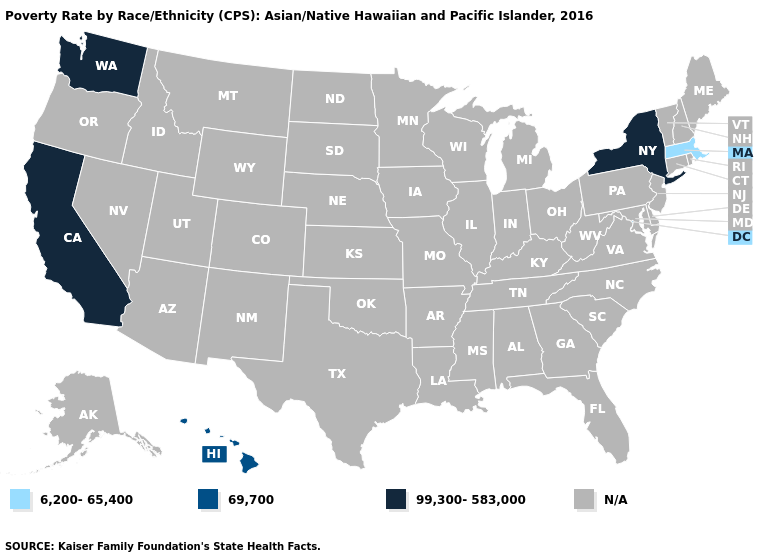What is the value of Arizona?
Give a very brief answer. N/A. Name the states that have a value in the range 99,300-583,000?
Be succinct. California, New York, Washington. Name the states that have a value in the range 6,200-65,400?
Quick response, please. Massachusetts. Does New York have the lowest value in the USA?
Concise answer only. No. Does New York have the highest value in the USA?
Be succinct. Yes. What is the value of Oregon?
Quick response, please. N/A. What is the value of Maryland?
Give a very brief answer. N/A. Name the states that have a value in the range 99,300-583,000?
Give a very brief answer. California, New York, Washington. Does Massachusetts have the highest value in the USA?
Give a very brief answer. No. Name the states that have a value in the range N/A?
Be succinct. Alabama, Alaska, Arizona, Arkansas, Colorado, Connecticut, Delaware, Florida, Georgia, Idaho, Illinois, Indiana, Iowa, Kansas, Kentucky, Louisiana, Maine, Maryland, Michigan, Minnesota, Mississippi, Missouri, Montana, Nebraska, Nevada, New Hampshire, New Jersey, New Mexico, North Carolina, North Dakota, Ohio, Oklahoma, Oregon, Pennsylvania, Rhode Island, South Carolina, South Dakota, Tennessee, Texas, Utah, Vermont, Virginia, West Virginia, Wisconsin, Wyoming. What is the lowest value in the USA?
Be succinct. 6,200-65,400. Name the states that have a value in the range N/A?
Short answer required. Alabama, Alaska, Arizona, Arkansas, Colorado, Connecticut, Delaware, Florida, Georgia, Idaho, Illinois, Indiana, Iowa, Kansas, Kentucky, Louisiana, Maine, Maryland, Michigan, Minnesota, Mississippi, Missouri, Montana, Nebraska, Nevada, New Hampshire, New Jersey, New Mexico, North Carolina, North Dakota, Ohio, Oklahoma, Oregon, Pennsylvania, Rhode Island, South Carolina, South Dakota, Tennessee, Texas, Utah, Vermont, Virginia, West Virginia, Wisconsin, Wyoming. Does New York have the highest value in the Northeast?
Keep it brief. Yes. 